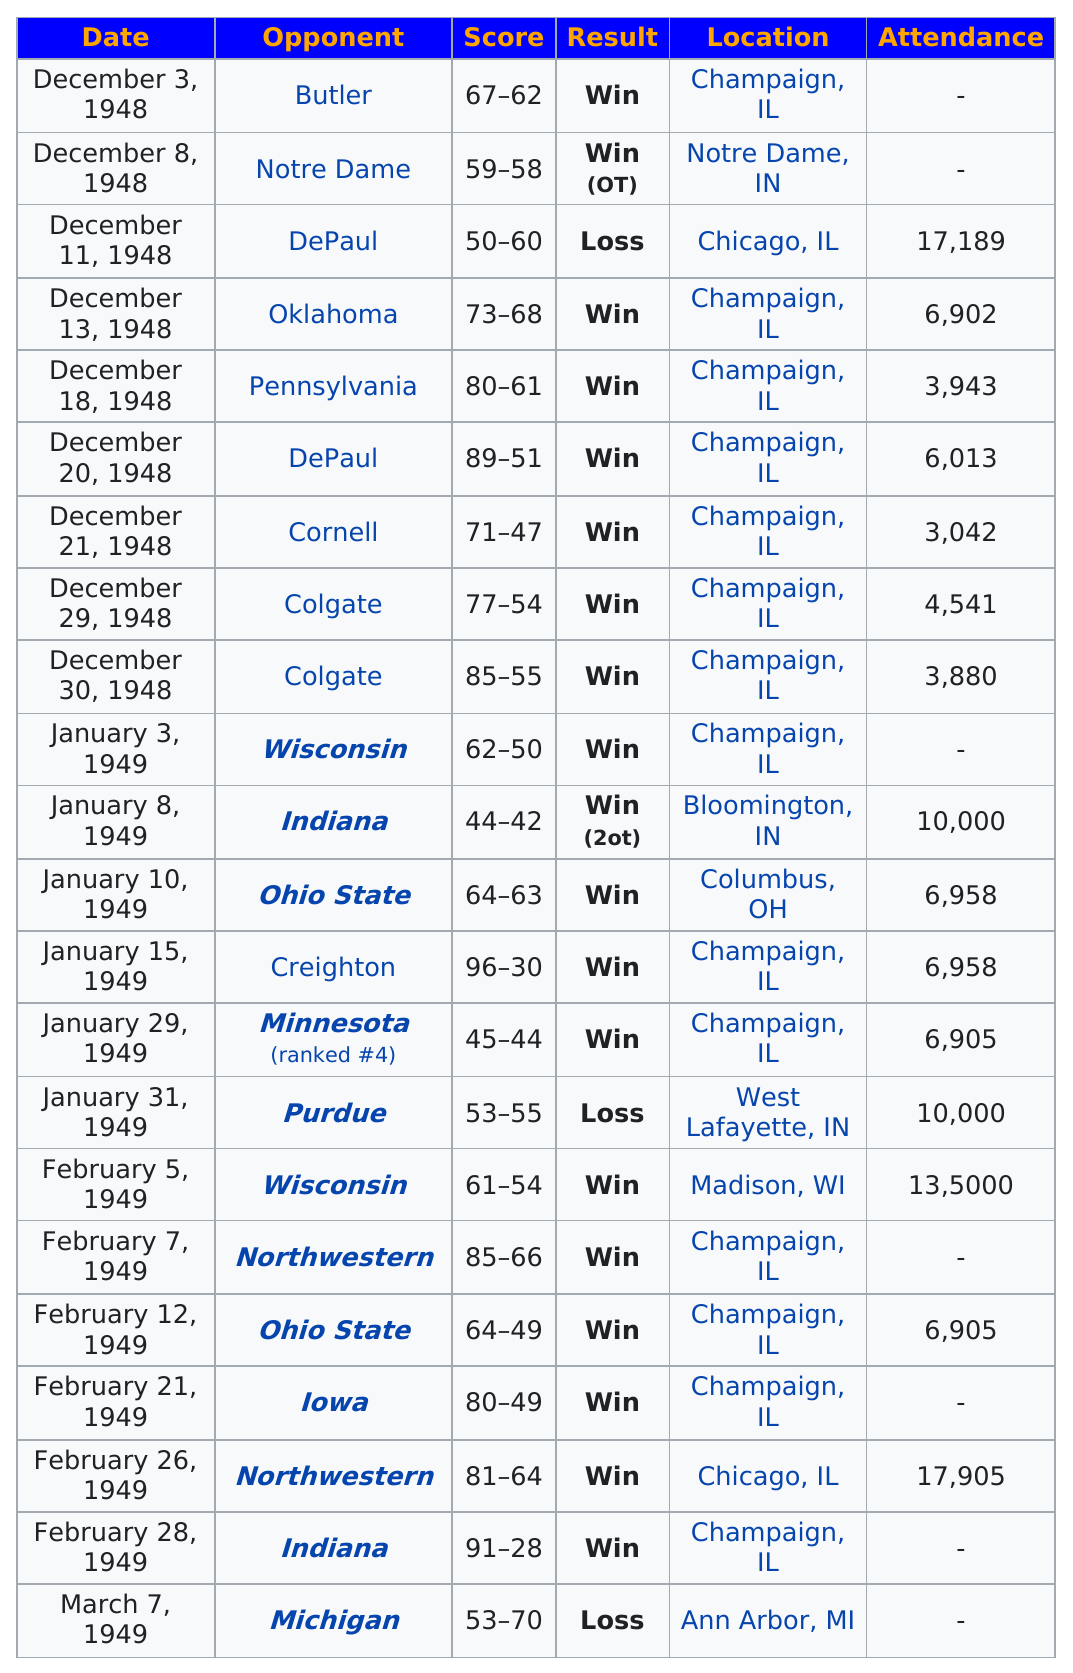Point out several critical features in this image. On January 8, the attendance at the game was larger than the attendance at the game on December 11, 1948. In 1949, the team achieved a total of 11 wins. Illinois scored more points in the first game than in the last game. In the game against Butler, more points were scored against us than in the game against Purdue. The team achieved six consecutive wins in 1948. 